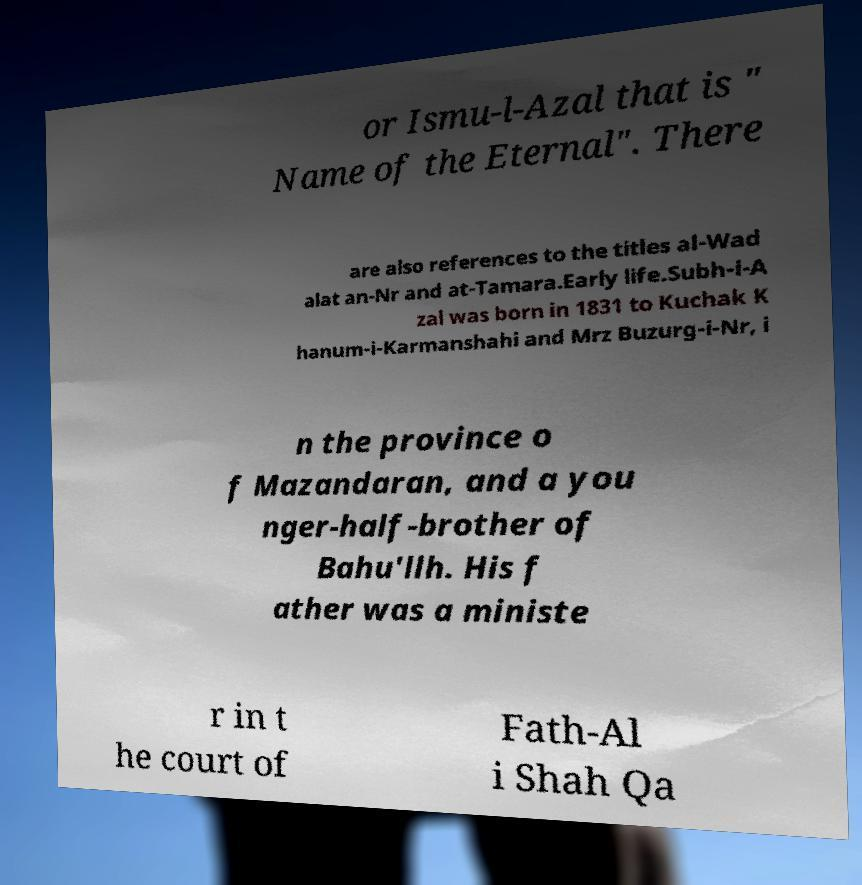Can you accurately transcribe the text from the provided image for me? or Ismu-l-Azal that is " Name of the Eternal". There are also references to the titles al-Wad alat an-Nr and at-Tamara.Early life.Subh-i-A zal was born in 1831 to Kuchak K hanum-i-Karmanshahi and Mrz Buzurg-i-Nr, i n the province o f Mazandaran, and a you nger-half-brother of Bahu'llh. His f ather was a ministe r in t he court of Fath-Al i Shah Qa 